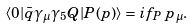<formula> <loc_0><loc_0><loc_500><loc_500>\langle 0 | \bar { q } \gamma _ { \mu } \gamma _ { 5 } Q | P ( p ) \rangle = i f _ { P } \, p _ { \mu } .</formula> 